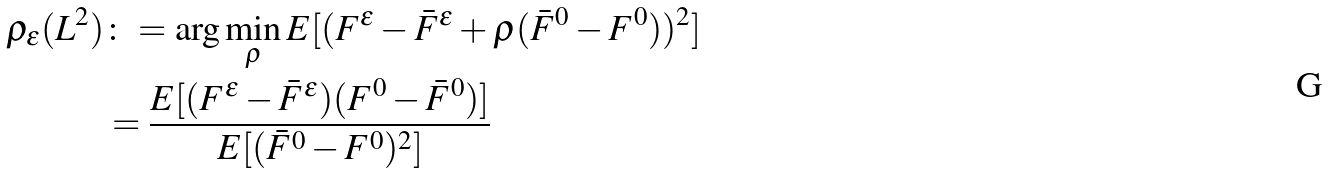<formula> <loc_0><loc_0><loc_500><loc_500>\rho _ { \epsilon } ( L ^ { 2 } ) & \colon = \arg \min _ { \rho } E [ ( F ^ { \epsilon } - \bar { F } ^ { \epsilon } + \rho ( \bar { F } ^ { 0 } - F ^ { 0 } ) ) ^ { 2 } ] \\ & = \frac { E [ ( F ^ { \epsilon } - \bar { F } ^ { \epsilon } ) ( F ^ { 0 } - \bar { F } ^ { 0 } ) ] } { E [ ( \bar { F } ^ { 0 } - F ^ { 0 } ) ^ { 2 } ] }</formula> 